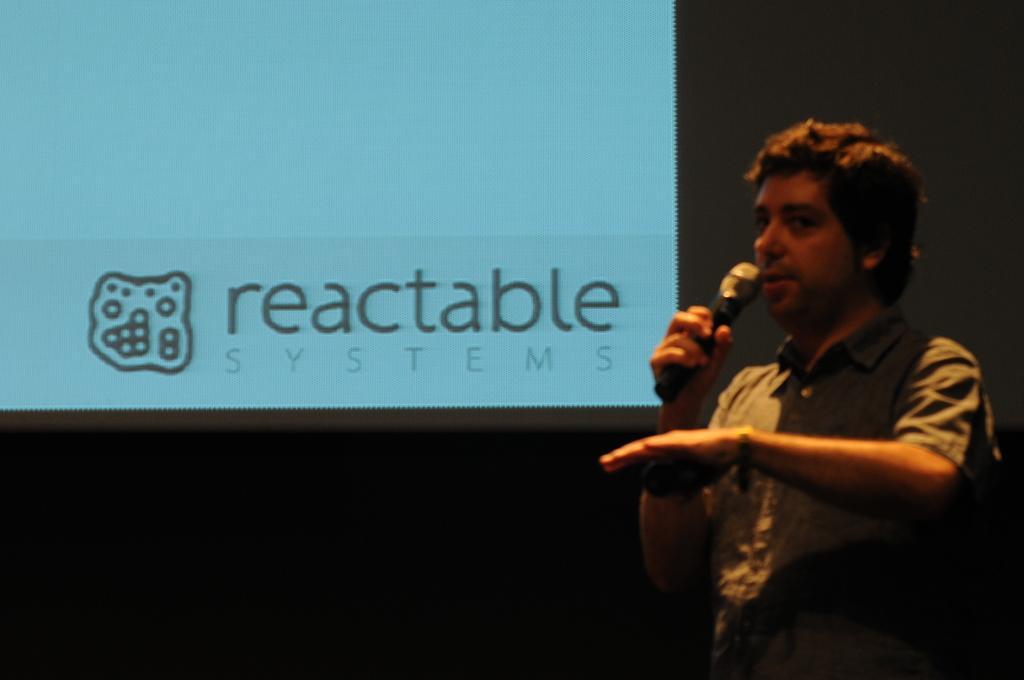Describe this image in one or two sentences. As we can see in the image there is a man holding mic and on the left side there is a screen. 